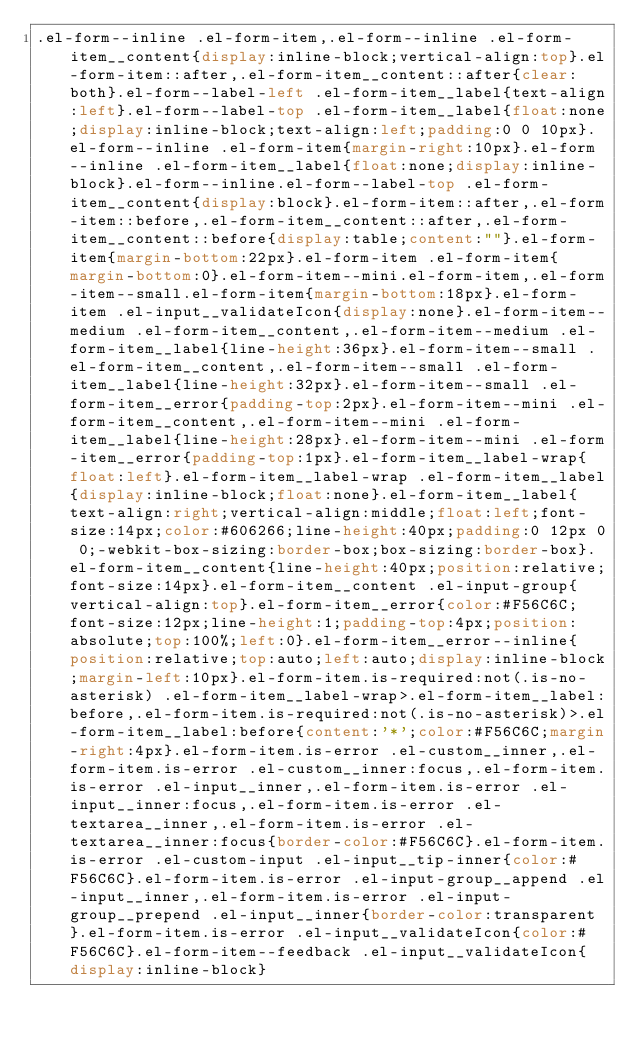<code> <loc_0><loc_0><loc_500><loc_500><_CSS_>.el-form--inline .el-form-item,.el-form--inline .el-form-item__content{display:inline-block;vertical-align:top}.el-form-item::after,.el-form-item__content::after{clear:both}.el-form--label-left .el-form-item__label{text-align:left}.el-form--label-top .el-form-item__label{float:none;display:inline-block;text-align:left;padding:0 0 10px}.el-form--inline .el-form-item{margin-right:10px}.el-form--inline .el-form-item__label{float:none;display:inline-block}.el-form--inline.el-form--label-top .el-form-item__content{display:block}.el-form-item::after,.el-form-item::before,.el-form-item__content::after,.el-form-item__content::before{display:table;content:""}.el-form-item{margin-bottom:22px}.el-form-item .el-form-item{margin-bottom:0}.el-form-item--mini.el-form-item,.el-form-item--small.el-form-item{margin-bottom:18px}.el-form-item .el-input__validateIcon{display:none}.el-form-item--medium .el-form-item__content,.el-form-item--medium .el-form-item__label{line-height:36px}.el-form-item--small .el-form-item__content,.el-form-item--small .el-form-item__label{line-height:32px}.el-form-item--small .el-form-item__error{padding-top:2px}.el-form-item--mini .el-form-item__content,.el-form-item--mini .el-form-item__label{line-height:28px}.el-form-item--mini .el-form-item__error{padding-top:1px}.el-form-item__label-wrap{float:left}.el-form-item__label-wrap .el-form-item__label{display:inline-block;float:none}.el-form-item__label{text-align:right;vertical-align:middle;float:left;font-size:14px;color:#606266;line-height:40px;padding:0 12px 0 0;-webkit-box-sizing:border-box;box-sizing:border-box}.el-form-item__content{line-height:40px;position:relative;font-size:14px}.el-form-item__content .el-input-group{vertical-align:top}.el-form-item__error{color:#F56C6C;font-size:12px;line-height:1;padding-top:4px;position:absolute;top:100%;left:0}.el-form-item__error--inline{position:relative;top:auto;left:auto;display:inline-block;margin-left:10px}.el-form-item.is-required:not(.is-no-asterisk) .el-form-item__label-wrap>.el-form-item__label:before,.el-form-item.is-required:not(.is-no-asterisk)>.el-form-item__label:before{content:'*';color:#F56C6C;margin-right:4px}.el-form-item.is-error .el-custom__inner,.el-form-item.is-error .el-custom__inner:focus,.el-form-item.is-error .el-input__inner,.el-form-item.is-error .el-input__inner:focus,.el-form-item.is-error .el-textarea__inner,.el-form-item.is-error .el-textarea__inner:focus{border-color:#F56C6C}.el-form-item.is-error .el-custom-input .el-input__tip-inner{color:#F56C6C}.el-form-item.is-error .el-input-group__append .el-input__inner,.el-form-item.is-error .el-input-group__prepend .el-input__inner{border-color:transparent}.el-form-item.is-error .el-input__validateIcon{color:#F56C6C}.el-form-item--feedback .el-input__validateIcon{display:inline-block}</code> 